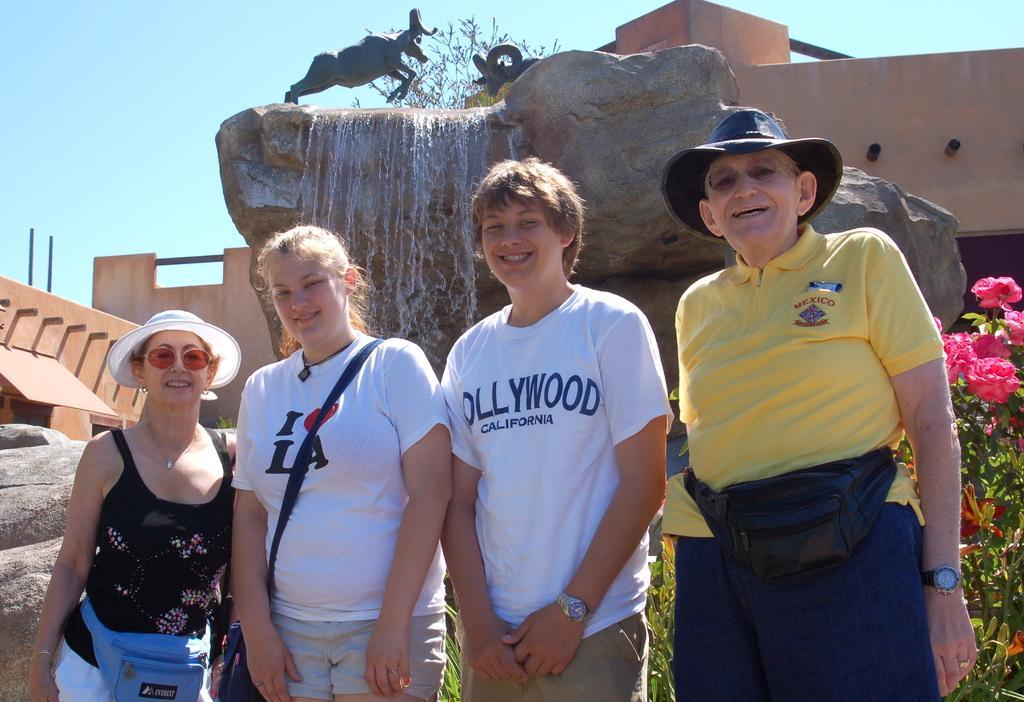Describe this image in one or two sentences. In this picture we can see an old man wearing yellow color t-shirt standing in the front, smiling and giving a pose into the camera. Beside there is a boy and a girl standing in the front and wearing a white t-shirt, smiling and giving a pose. Behind there is a mountain with a small waterfall and two deer statue on the top. On the left corner we can see the brown color wall. 